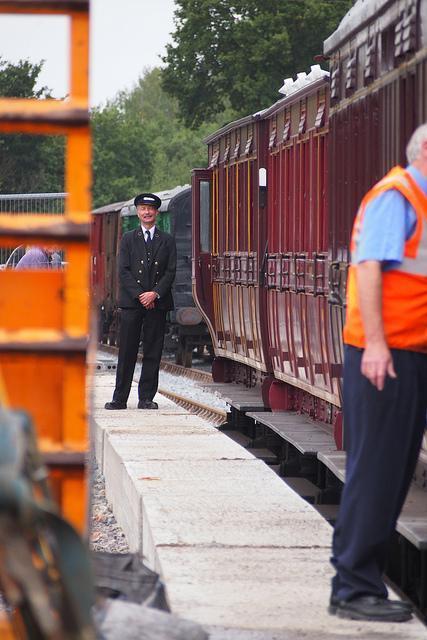How many trains are visible?
Give a very brief answer. 2. How many people can be seen?
Give a very brief answer. 2. How many pizzas are there?
Give a very brief answer. 0. 